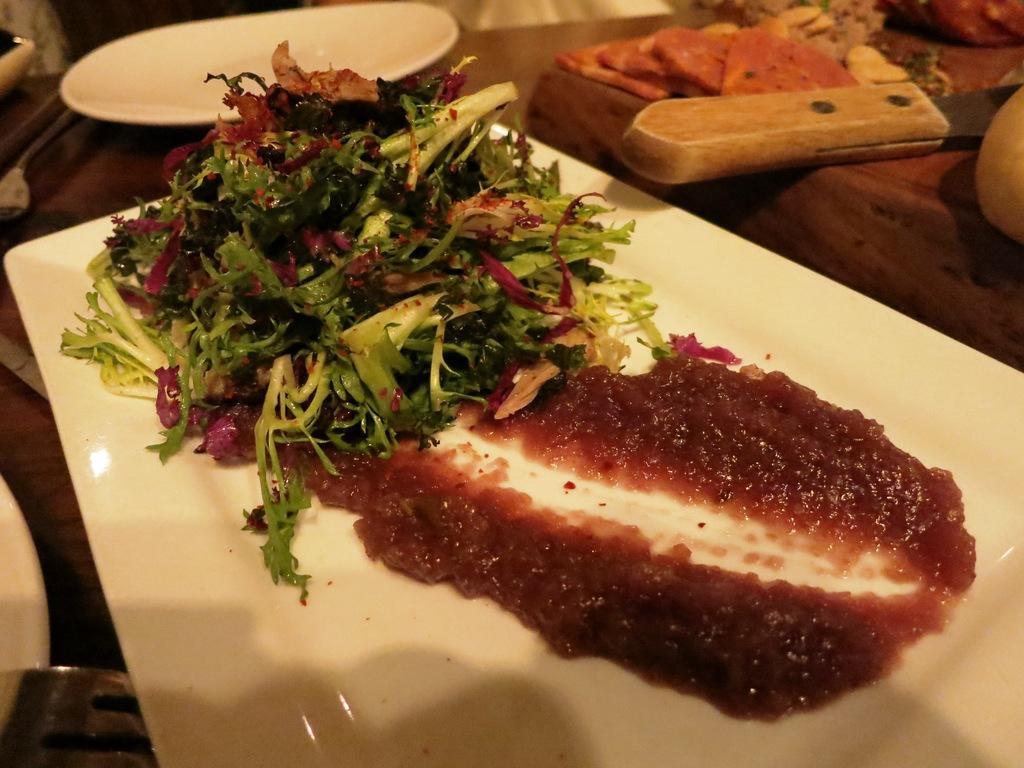How would you summarize this image in a sentence or two? In this picture I can see food in the tray and I can see couple of plates and a knife and food in the bowls on the table. 